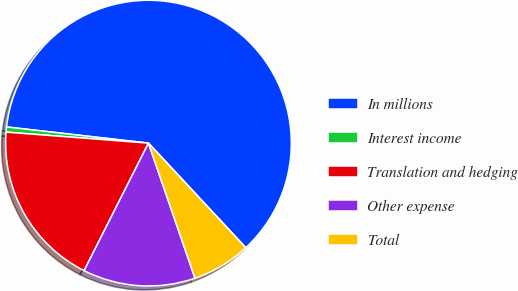Convert chart. <chart><loc_0><loc_0><loc_500><loc_500><pie_chart><fcel>In millions<fcel>Interest income<fcel>Translation and hedging<fcel>Other expense<fcel>Total<nl><fcel>61.27%<fcel>0.58%<fcel>18.79%<fcel>12.72%<fcel>6.65%<nl></chart> 